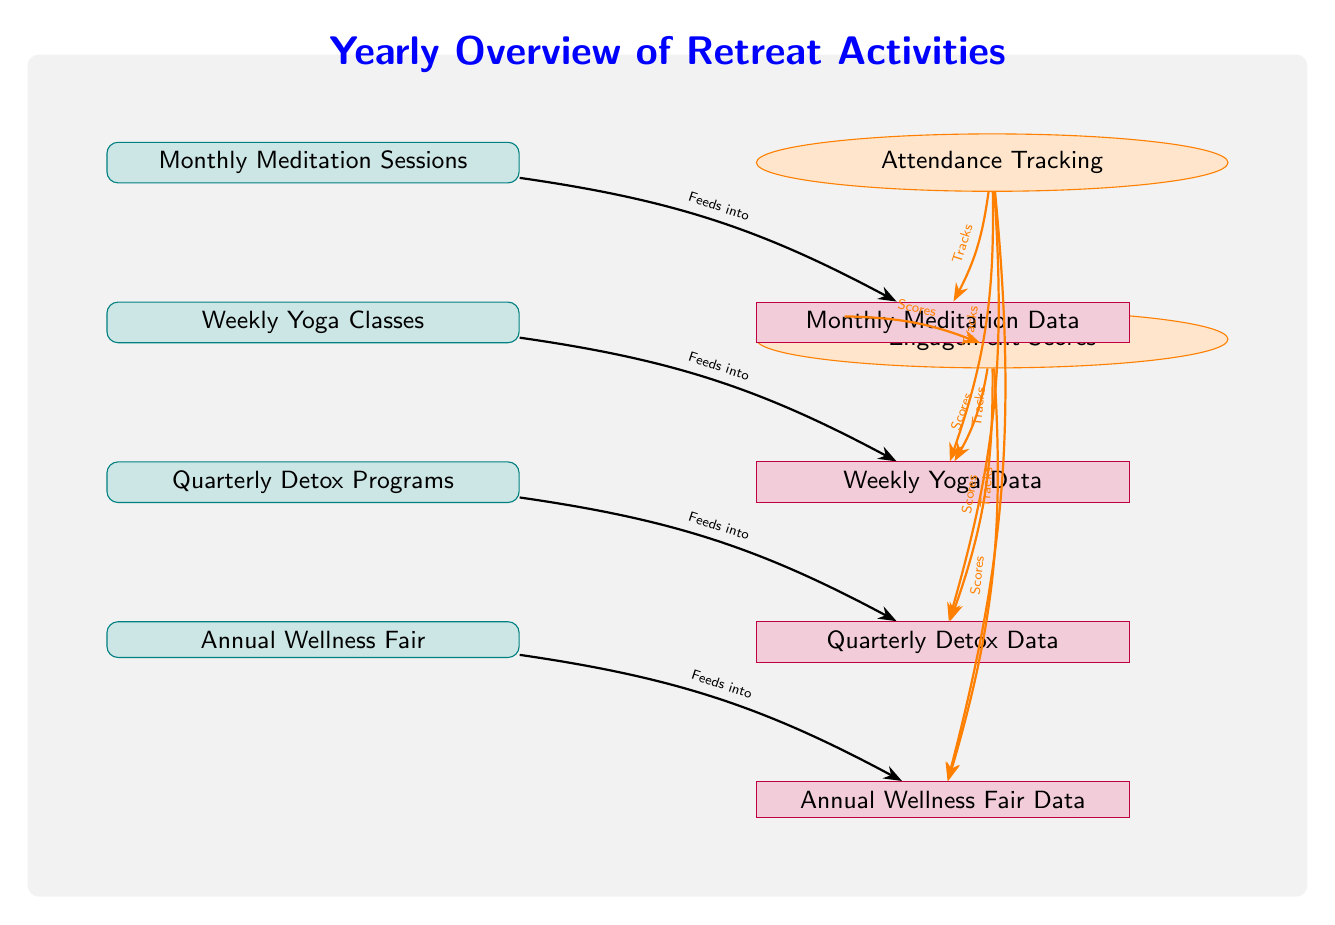What are the activities offered at the retreat? The diagram lists four activities: Monthly Meditation Sessions, Weekly Yoga Classes, Quarterly Detox Programs, and Annual Wellness Fair.
Answer: Monthly Meditation Sessions, Weekly Yoga Classes, Quarterly Detox Programs, Annual Wellness Fair How many metrics are shown on the diagram? There are two metrics shown: Attendance Tracking and Engagement Scores.
Answer: 2 What type of activity occurs quarterly? The diagram specifies "Quarterly Detox Programs" as the activity that occurs quarterly.
Answer: Quarterly Detox Programs Which activity is tracked first in terms of the data flow? The Monthly Meditation Sessions feeds into the Monthly Meditation Data, making it the first activity in the data tracking flow.
Answer: Monthly Meditation Sessions Which metric is associated with the Annual Wellness Fair data? Both Attendance Tracking and Engagement Scores metrics apply to Annual Wellness Fair Data as indicated by the arrows directed towards that data node.
Answer: Attendance Tracking, Engagement Scores What is the relationship between the engagement metric and the meditation data? The Engagement Scores metric provides scores to the Monthly Meditation Data, as shown by the arrow connecting them.
Answer: Scores How many data nodes correspond to the activities? There are four data nodes corresponding to the activities: Monthly Meditation Data, Weekly Yoga Data, Quarterly Detox Data, and Annual Wellness Fair Data.
Answer: 4 What type of diagram is represented? The structure and purpose of the diagram categorize it as a Textbook Diagram, as it visually outlines activities, metrics, and data flow.
Answer: Textbook Diagram Which activity is likely to attract the most participants, based on the diagram's structure? The Annual Wellness Fair, being a major yearly event, likely attracts the most participants, as it’s the only annual event listed.
Answer: Annual Wellness Fair 